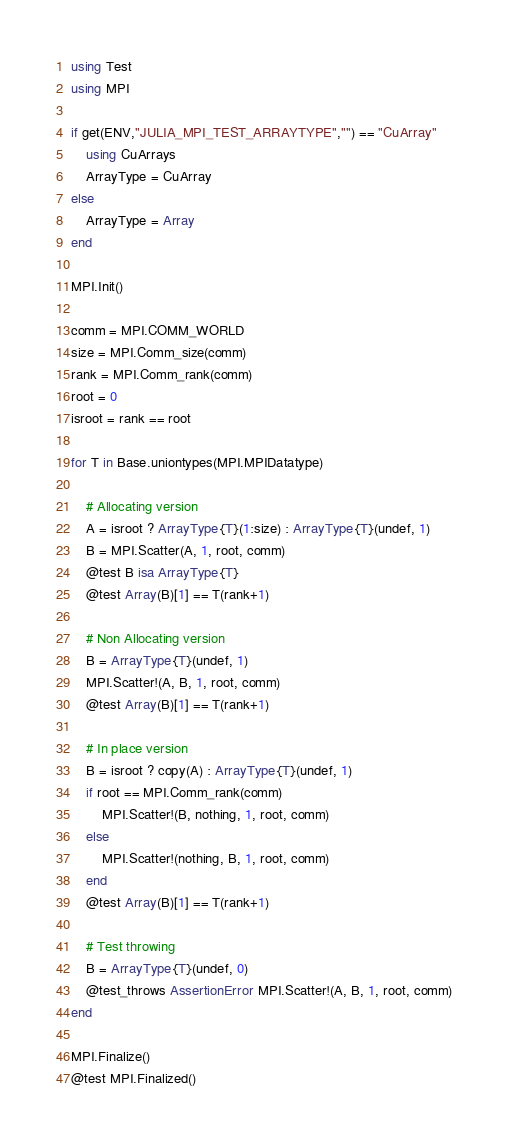Convert code to text. <code><loc_0><loc_0><loc_500><loc_500><_Julia_>using Test
using MPI

if get(ENV,"JULIA_MPI_TEST_ARRAYTYPE","") == "CuArray"
    using CuArrays
    ArrayType = CuArray
else
    ArrayType = Array
end

MPI.Init()

comm = MPI.COMM_WORLD
size = MPI.Comm_size(comm)
rank = MPI.Comm_rank(comm)
root = 0
isroot = rank == root

for T in Base.uniontypes(MPI.MPIDatatype)

    # Allocating version
    A = isroot ? ArrayType{T}(1:size) : ArrayType{T}(undef, 1)
    B = MPI.Scatter(A, 1, root, comm)
    @test B isa ArrayType{T}
    @test Array(B)[1] == T(rank+1)

    # Non Allocating version
    B = ArrayType{T}(undef, 1)
    MPI.Scatter!(A, B, 1, root, comm)
    @test Array(B)[1] == T(rank+1)

    # In place version
    B = isroot ? copy(A) : ArrayType{T}(undef, 1)
    if root == MPI.Comm_rank(comm)
        MPI.Scatter!(B, nothing, 1, root, comm)
    else
        MPI.Scatter!(nothing, B, 1, root, comm)
    end
    @test Array(B)[1] == T(rank+1)

    # Test throwing
    B = ArrayType{T}(undef, 0)
    @test_throws AssertionError MPI.Scatter!(A, B, 1, root, comm)
end

MPI.Finalize()
@test MPI.Finalized()
</code> 